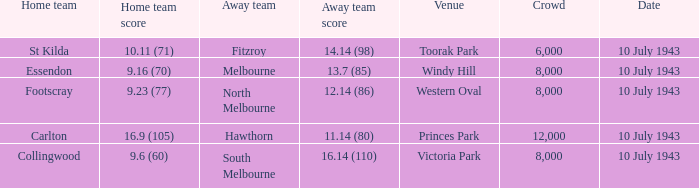Could you parse the entire table? {'header': ['Home team', 'Home team score', 'Away team', 'Away team score', 'Venue', 'Crowd', 'Date'], 'rows': [['St Kilda', '10.11 (71)', 'Fitzroy', '14.14 (98)', 'Toorak Park', '6,000', '10 July 1943'], ['Essendon', '9.16 (70)', 'Melbourne', '13.7 (85)', 'Windy Hill', '8,000', '10 July 1943'], ['Footscray', '9.23 (77)', 'North Melbourne', '12.14 (86)', 'Western Oval', '8,000', '10 July 1943'], ['Carlton', '16.9 (105)', 'Hawthorn', '11.14 (80)', 'Princes Park', '12,000', '10 July 1943'], ['Collingwood', '9.6 (60)', 'South Melbourne', '16.14 (110)', 'Victoria Park', '8,000', '10 July 1943']]} When the Away team scored 14.14 (98), which Venue did the game take place? Toorak Park. 